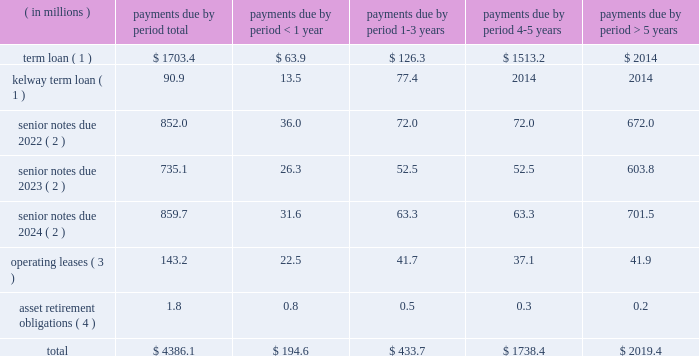Table of contents ended december 31 , 2015 and 2014 , respectively .
The increase in cash provided by accounts payable-inventory financing was primarily due to a new vendor added to our previously existing inventory financing agreement .
For a description of the inventory financing transactions impacting each period , see note 6 ( inventory financing agreements ) to the accompanying consolidated financial statements .
For a description of the debt transactions impacting each period , see note 8 ( long-term debt ) to the accompanying consolidated financial statements .
Net cash used in financing activities decreased $ 56.3 million in 2014 compared to 2013 .
The decrease was primarily driven by several debt refinancing transactions during each period and our july 2013 ipo , which generated net proceeds of $ 424.7 million after deducting underwriting discounts , expenses and transaction costs .
The net impact of our debt transactions resulted in cash outflows of $ 145.9 million and $ 518.3 million during 2014 and 2013 , respectively , as cash was used in each period to reduce our total long-term debt .
For a description of the debt transactions impacting each period , see note 8 ( long-term debt ) to the accompanying consolidated financial statements .
Long-term debt and financing arrangements as of december 31 , 2015 , we had total indebtedness of $ 3.3 billion , of which $ 1.6 billion was secured indebtedness .
At december 31 , 2015 , we were in compliance with the covenants under our various credit agreements and indentures .
The amount of cdw 2019s restricted payment capacity under the senior secured term loan facility was $ 679.7 million at december 31 , 2015 .
For further details regarding our debt and each of the transactions described below , see note 8 ( long-term debt ) to the accompanying consolidated financial statements .
During the year ended december 31 , 2015 , the following events occurred with respect to our debt structure : 2022 on august 1 , 2015 , we consolidated kelway 2019s term loan and kelway 2019s revolving credit facility .
Kelway 2019s term loan is denominated in british pounds .
The kelway revolving credit facility is a multi-currency revolving credit facility under which kelway is permitted to borrow an aggregate amount of a350.0 million ( $ 73.7 million ) as of december 31 , 2015 .
2022 on march 3 , 2015 , we completed the issuance of $ 525.0 million principal amount of 5.0% ( 5.0 % ) senior notes due 2023 which will mature on september 1 , 2023 .
2022 on march 3 , 2015 , we redeemed the remaining $ 503.9 million aggregate principal amount of the 8.5% ( 8.5 % ) senior notes due 2019 , plus accrued and unpaid interest through the date of redemption , april 2 , 2015 .
Inventory financing agreements we have entered into agreements with certain financial intermediaries to facilitate the purchase of inventory from various suppliers under certain terms and conditions .
These amounts are classified separately as accounts payable-inventory financing on the consolidated balance sheets .
We do not incur any interest expense associated with these agreements as balances are paid when they are due .
For further details , see note 6 ( inventory financing agreements ) to the accompanying consolidated financial statements .
Contractual obligations we have future obligations under various contracts relating to debt and interest payments , operating leases and asset retirement obligations .
Our estimated future payments , based on undiscounted amounts , under contractual obligations that existed as of december 31 , 2015 , are as follows: .

Operating leases are what percent of total obligations? 
Computations: (143.2 / 4386.1)
Answer: 0.03265. 